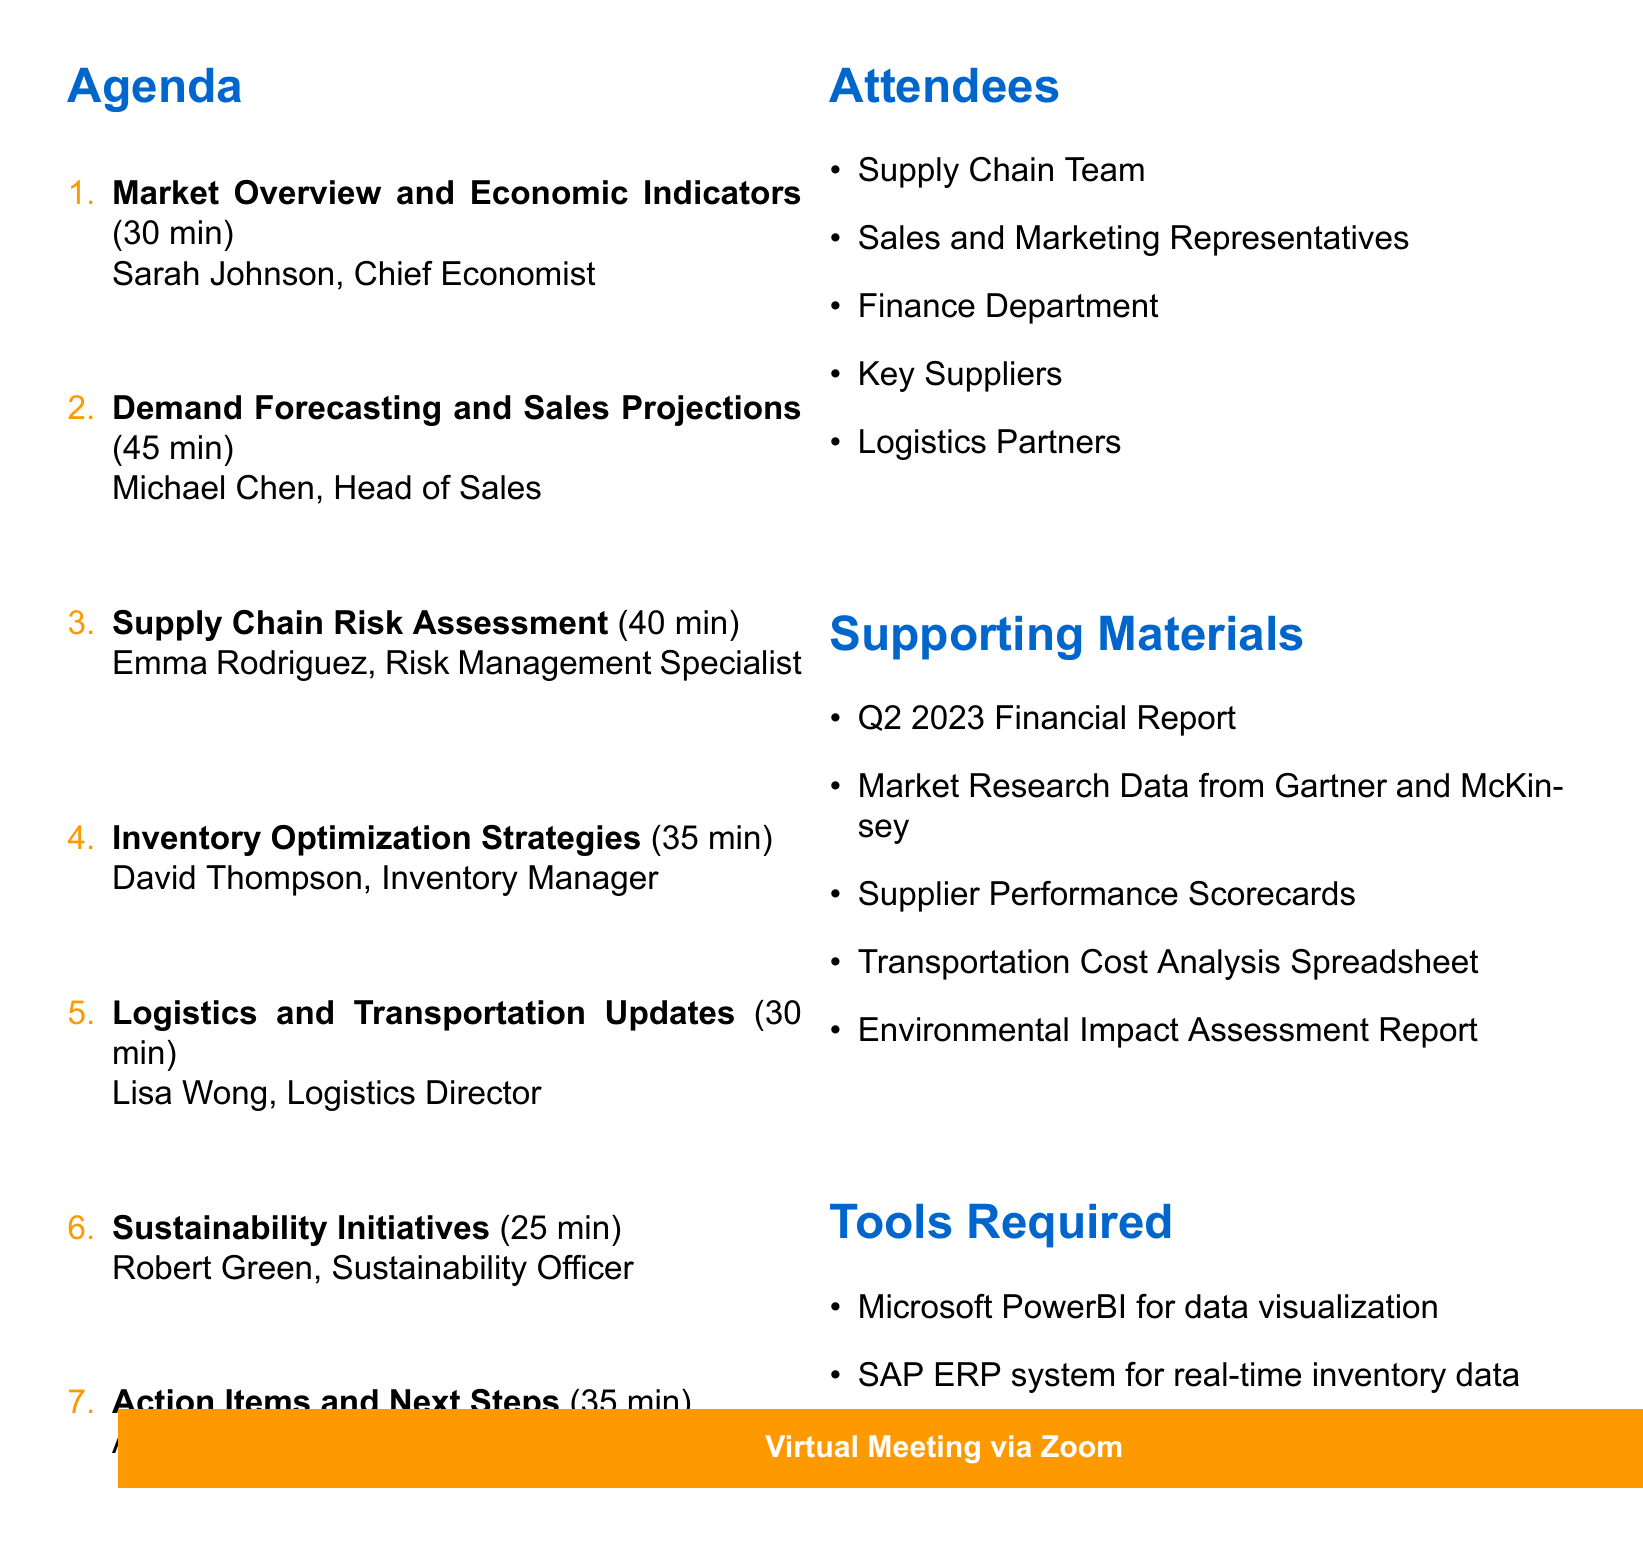What is the date of the meeting? The date of the meeting can be found in the document under the meeting details.
Answer: July 15, 2023 Who is the presenter for the Supply Chain Risk Assessment? The presenter's name for this agenda item is listed alongside the title in the document.
Answer: Emma Rodriguez How long is the Logistics and Transportation Updates session? This duration is specified within the agenda items in the document.
Answer: 30 minutes What is one of the supporting materials provided for the meeting? The document lists supporting materials that will be used during the meeting.
Answer: Q2 2023 Financial Report Which department does Michael Chen represent? The document indicates the role and department of each presenter associated with the agenda items.
Answer: Sales What is the last agenda item discussed in the meeting? The document lists agenda items in order, allowing us to identify the last one.
Answer: Action Items and Next Steps How many attendees are listed in the document? The total number of attendees is found in the attendees section of the document.
Answer: Five What tool is required for data visualization? The document lists the tools required for the meeting, including their specific purposes.
Answer: Microsoft PowerBI 